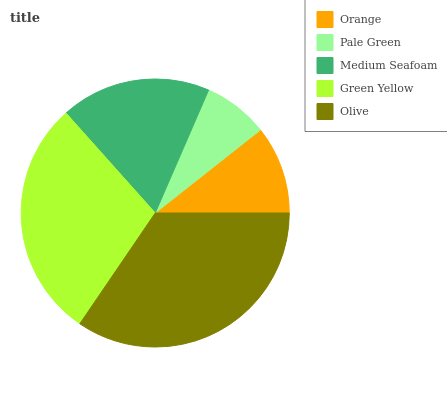Is Pale Green the minimum?
Answer yes or no. Yes. Is Olive the maximum?
Answer yes or no. Yes. Is Medium Seafoam the minimum?
Answer yes or no. No. Is Medium Seafoam the maximum?
Answer yes or no. No. Is Medium Seafoam greater than Pale Green?
Answer yes or no. Yes. Is Pale Green less than Medium Seafoam?
Answer yes or no. Yes. Is Pale Green greater than Medium Seafoam?
Answer yes or no. No. Is Medium Seafoam less than Pale Green?
Answer yes or no. No. Is Medium Seafoam the high median?
Answer yes or no. Yes. Is Medium Seafoam the low median?
Answer yes or no. Yes. Is Green Yellow the high median?
Answer yes or no. No. Is Olive the low median?
Answer yes or no. No. 